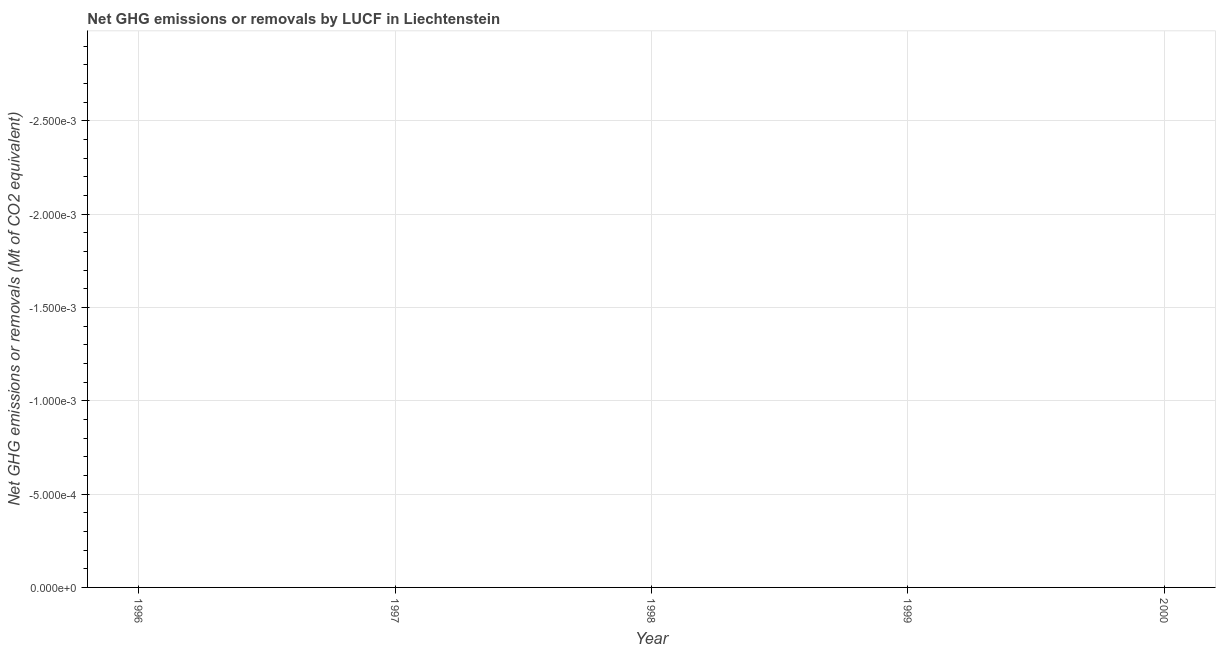What is the ghg net emissions or removals in 1998?
Provide a short and direct response. 0. Across all years, what is the minimum ghg net emissions or removals?
Keep it short and to the point. 0. What is the median ghg net emissions or removals?
Provide a short and direct response. 0. Does the ghg net emissions or removals monotonically increase over the years?
Keep it short and to the point. No. What is the difference between two consecutive major ticks on the Y-axis?
Make the answer very short. 0. Are the values on the major ticks of Y-axis written in scientific E-notation?
Your answer should be compact. Yes. Does the graph contain any zero values?
Offer a terse response. Yes. Does the graph contain grids?
Your answer should be very brief. Yes. What is the title of the graph?
Your answer should be very brief. Net GHG emissions or removals by LUCF in Liechtenstein. What is the label or title of the X-axis?
Keep it short and to the point. Year. What is the label or title of the Y-axis?
Ensure brevity in your answer.  Net GHG emissions or removals (Mt of CO2 equivalent). What is the Net GHG emissions or removals (Mt of CO2 equivalent) of 1998?
Your answer should be very brief. 0. What is the Net GHG emissions or removals (Mt of CO2 equivalent) in 1999?
Ensure brevity in your answer.  0. 